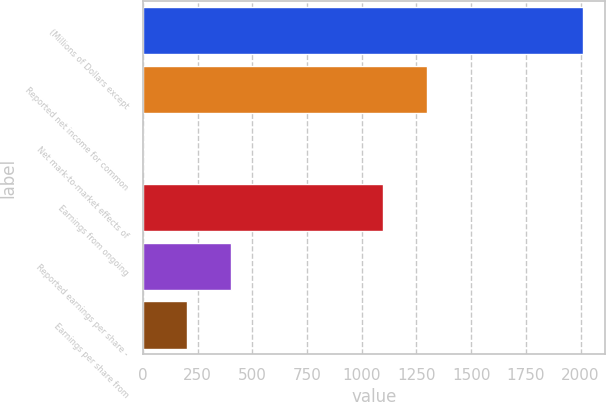Convert chart. <chart><loc_0><loc_0><loc_500><loc_500><bar_chart><fcel>(Millions of Dollars except<fcel>Reported net income for common<fcel>Net mark-to-market effects of<fcel>Earnings from ongoing<fcel>Reported earnings per share -<fcel>Earnings per share from<nl><fcel>2012<fcel>1299.19<fcel>0.13<fcel>1098<fcel>402.51<fcel>201.32<nl></chart> 